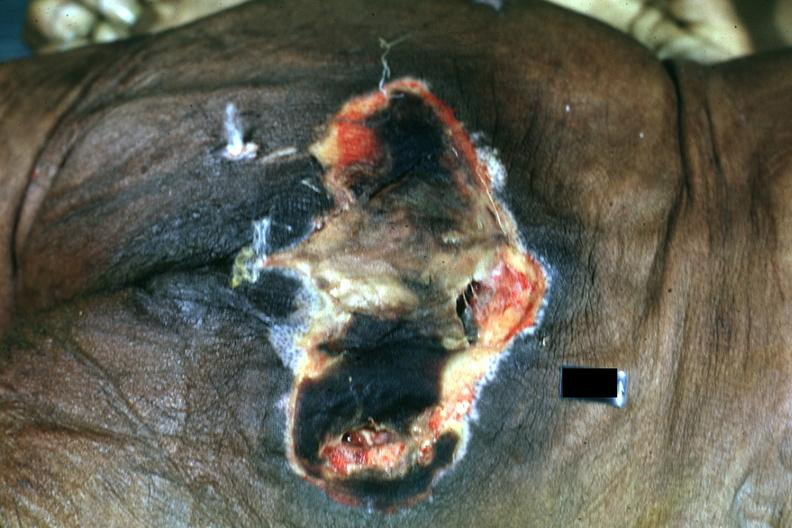what is present?
Answer the question using a single word or phrase. Decubitus ulcer 